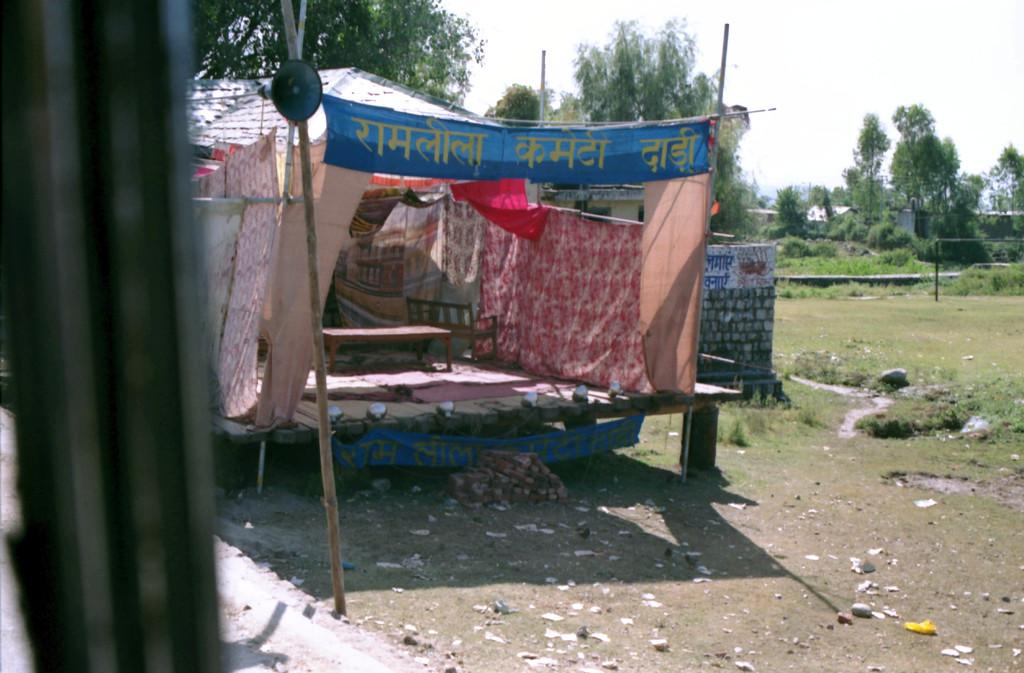What is located in the foreground of the image? There is a stall in the foreground of the image. What can be seen in the background of the image? There are trees and houses in the background of the image. What is visible in the sky in the image? The sky is visible in the background of the image. What type of shade does the partner use to protect themselves from the sun in the image? There is no partner present in the image, and therefore no shade can be associated with them. 